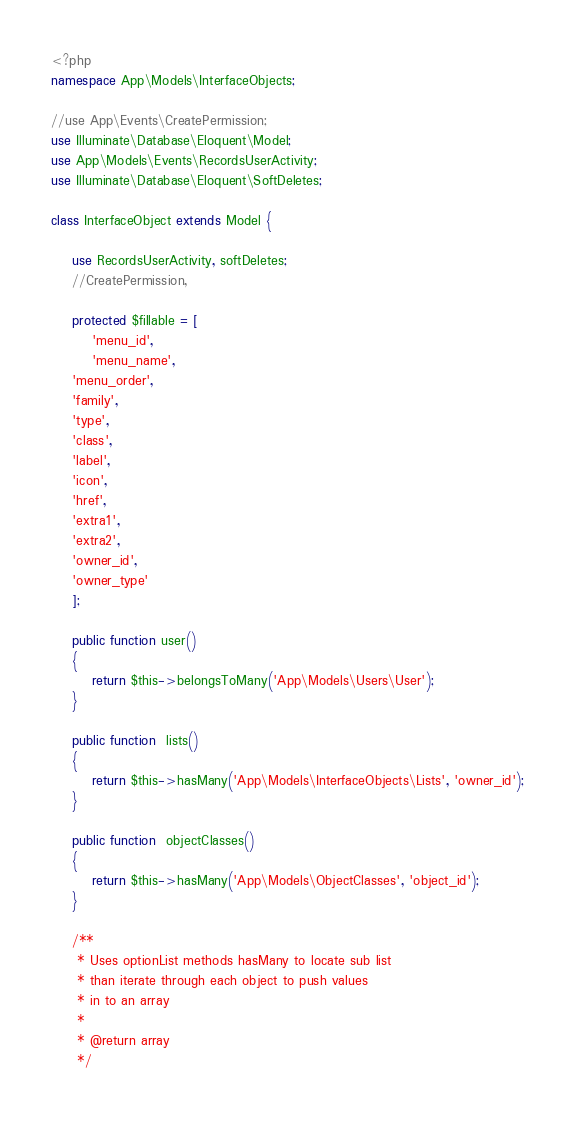Convert code to text. <code><loc_0><loc_0><loc_500><loc_500><_PHP_><?php
namespace App\Models\InterfaceObjects;

//use App\Events\CreatePermission;
use Illuminate\Database\Eloquent\Model;
use App\Models\Events\RecordsUserActivity;
use Illuminate\Database\Eloquent\SoftDeletes;

class InterfaceObject extends Model {

	use RecordsUserActivity, softDeletes;
	//CreatePermission, 

	protected $fillable = [
		'menu_id',
		'menu_name',
    'menu_order',
    'family',
    'type',
    'class',
    'label',
    'icon',
    'href',
    'extra1',
    'extra2',
    'owner_id',
    'owner_type'
	];

	public function user()
	{
		return $this->belongsToMany('App\Models\Users\User');
	}

	public function  lists()
	{
		return $this->hasMany('App\Models\InterfaceObjects\Lists', 'owner_id');
	}

	public function  objectClasses()
	{
		return $this->hasMany('App\Models\ObjectClasses', 'object_id');
	}

	/**
	 * Uses optionList methods hasMany to locate sub list
	 * than iterate through each object to push values
	 * in to an array
	 *
	 * @return array
	 */</code> 